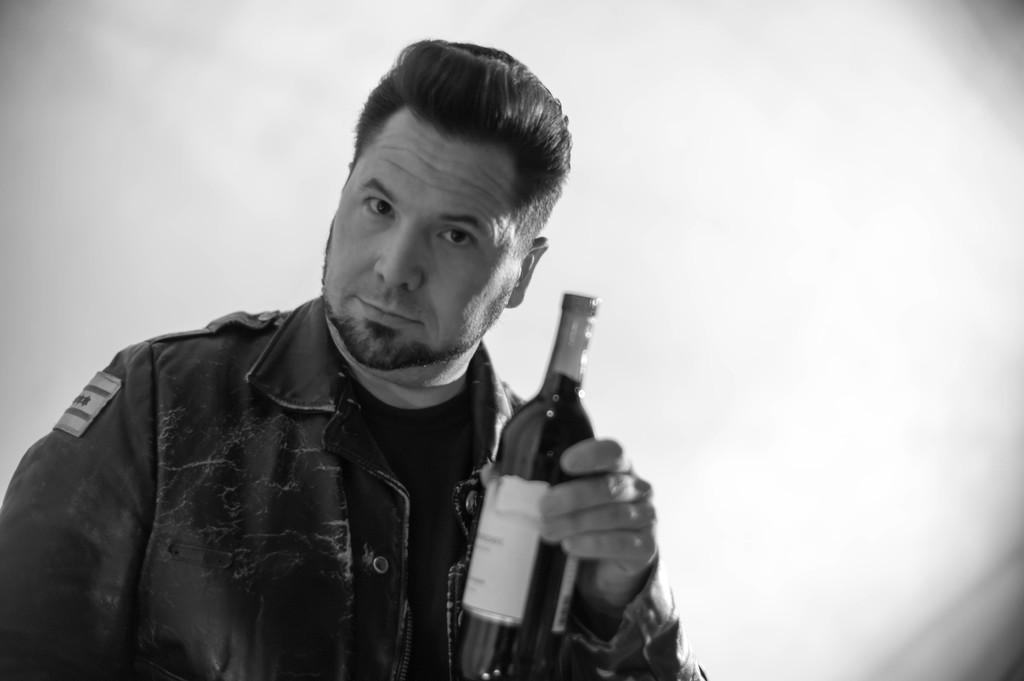What is present in the image? There is a man in the image. What is the man holding in his hand? The man is holding a glass bottle in his hand. What is the man's desire for the cup in the image? There is no cup present in the image, and therefore no such desire can be observed. 